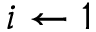Convert formula to latex. <formula><loc_0><loc_0><loc_500><loc_500>i \gets 1</formula> 